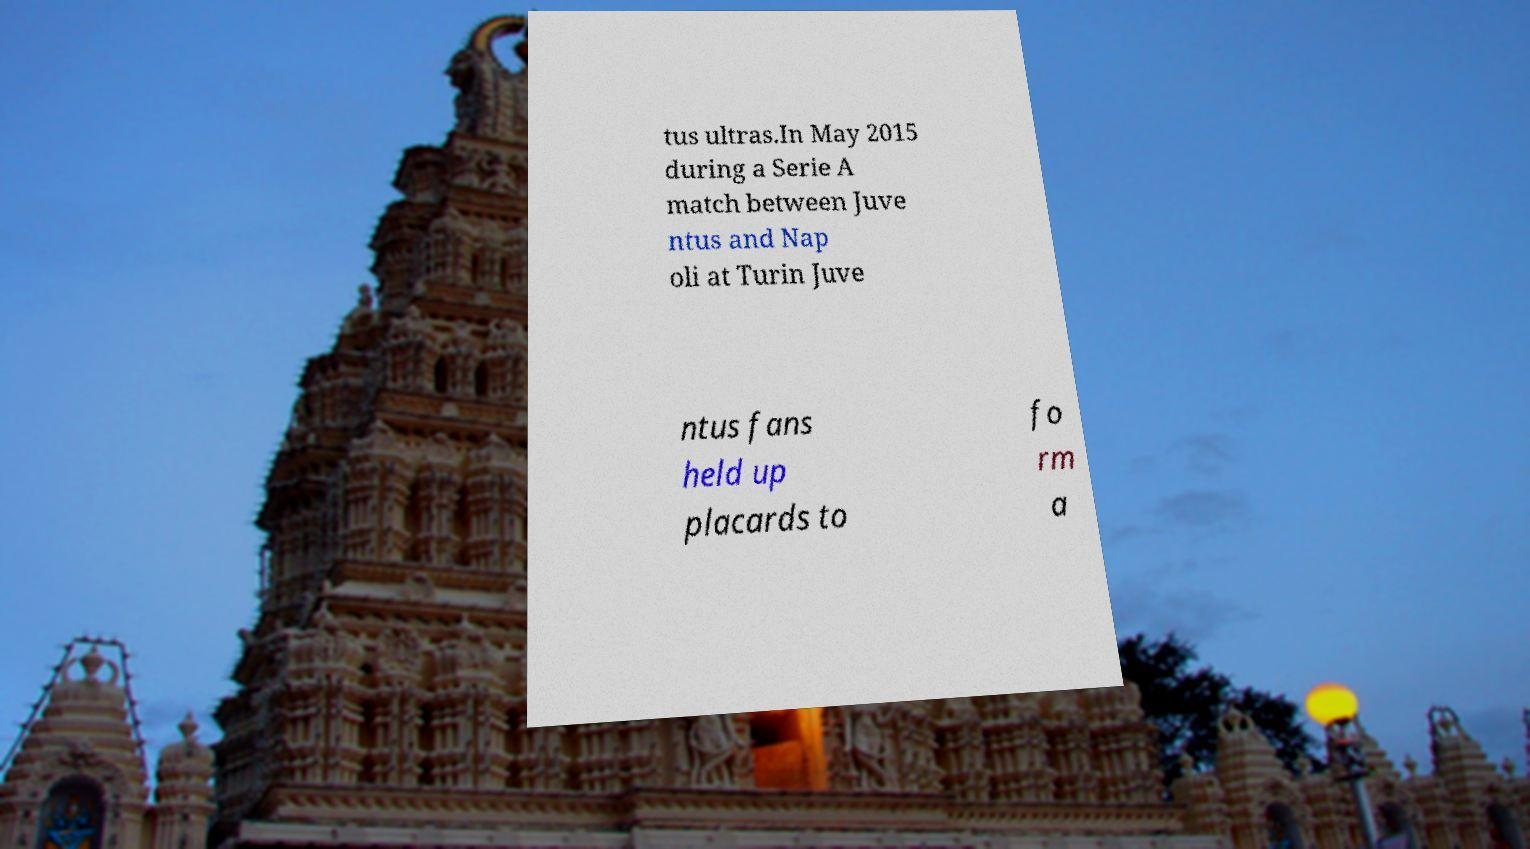There's text embedded in this image that I need extracted. Can you transcribe it verbatim? tus ultras.In May 2015 during a Serie A match between Juve ntus and Nap oli at Turin Juve ntus fans held up placards to fo rm a 